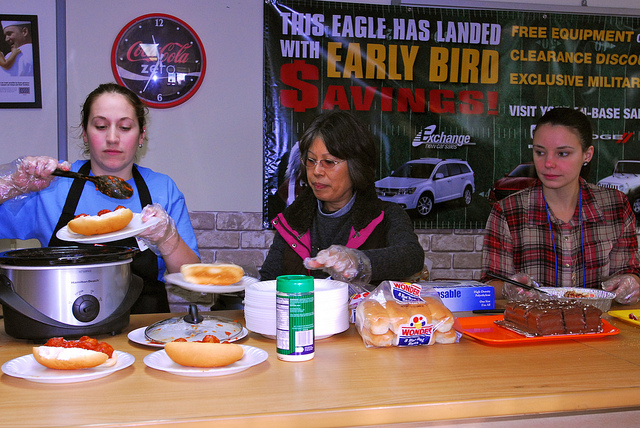Read all the text in this image. THIS EAGLE HAS EARLY BIRD WONDER WONDER SA BASE V VISIT EXCLUSIVE MILITAR DISCO CLEARANCE EQUIPMENT FREE LANDED Exchange AVINGS $ WITH 12 6 CocaCola 